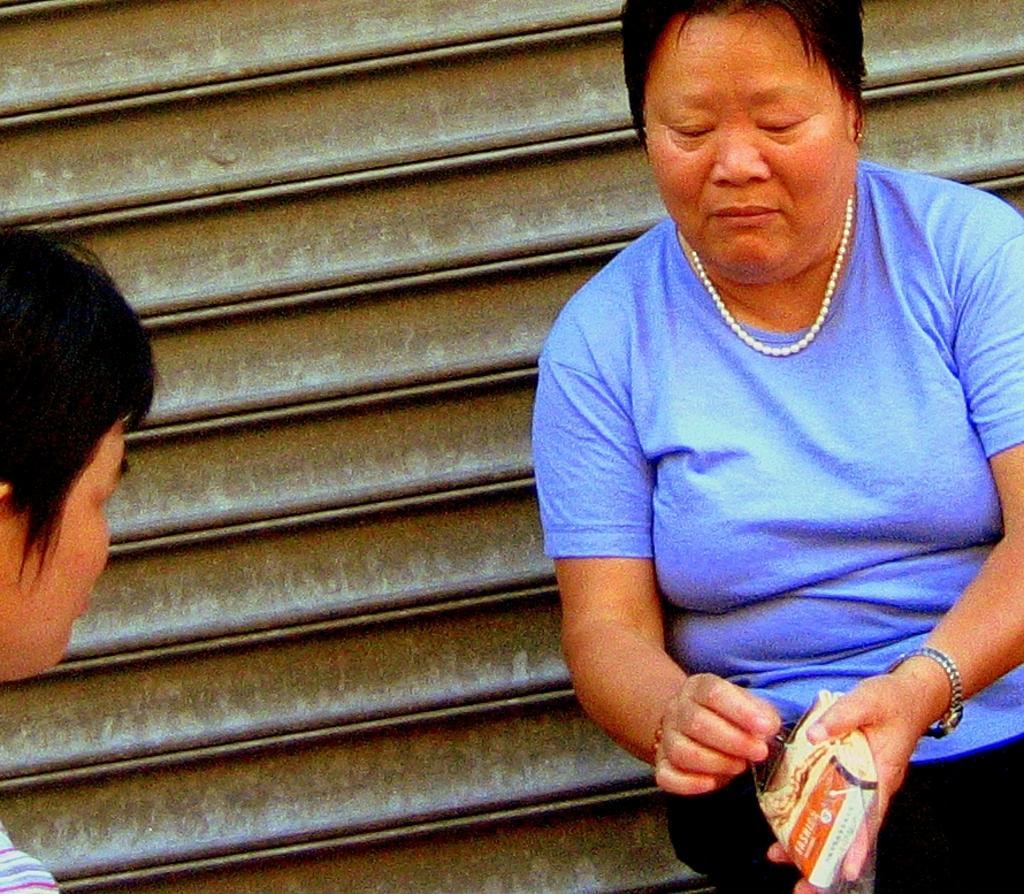How would you summarize this image in a sentence or two? In the image in the center we can see one woman sitting and holding some object. On the left side of the image we can see one person. In the background there is a shutter. 